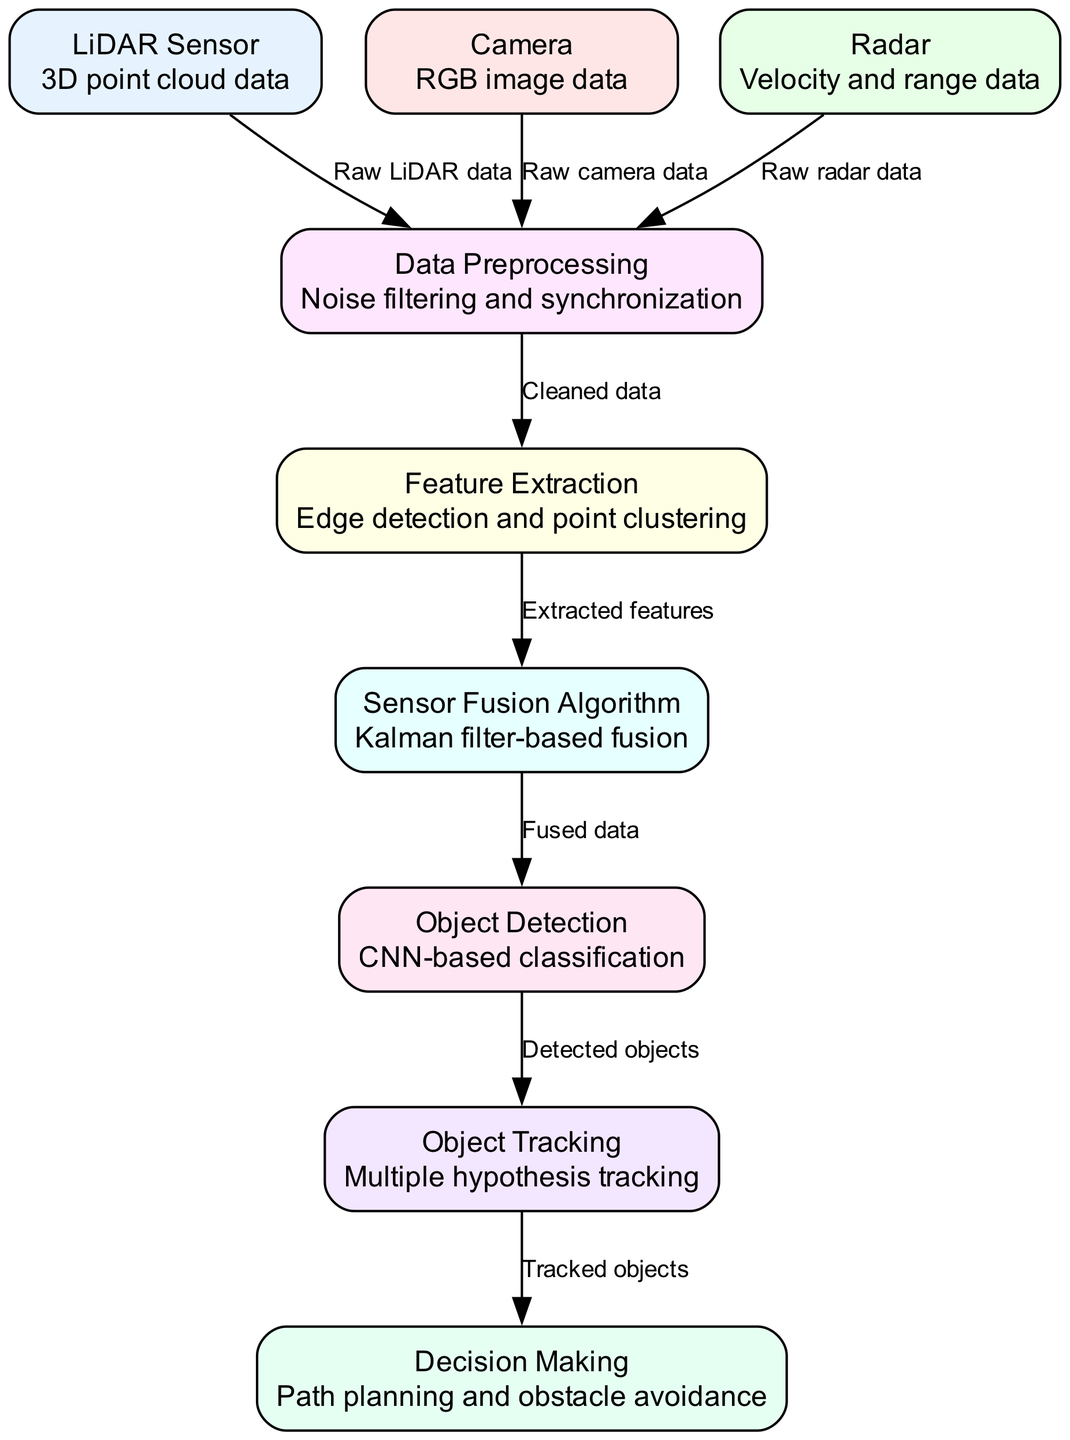What are the three types of sensors used in this diagram? The diagram lists three sensors: LiDAR, Camera, and Radar, which are essential for capturing different types of data.
Answer: LiDAR, Camera, Radar How many nodes are present in the diagram? By counting the nodes listed in the generated diagram data, we find a total of nine distinct nodes representing various components of the system.
Answer: Nine What is the output of the Data Preprocessing node? The output from the Data Preprocessing node is referred to as "Cleaned data," which signifies that the raw data has been modified for further processing.
Answer: Cleaned data What algorithm is used in the Sensor Fusion Algorithm node? The algorithm specified in the Sensor Fusion Algorithm node is based on the Kalman filter, which is a widely used mathematical method for estimating the state of a dynamic system.
Answer: Kalman filter How is object tracking achieved according to the diagram? Object tracking in the diagram is achieved using "Multiple hypothesis tracking," a technique that maintains several possible trajectories for each detected object to determine its accurate path over time.
Answer: Multiple hypothesis tracking What type of data does the Camera provide? The Camera node in the diagram is associated with RGB image data, which provides color visual information for processing and analysis.
Answer: RGB image data Which node represents the final decision-making process in the diagram? The Decision Making node in the diagram signifies the endpoint for processing, where path planning and obstacle avoidance decisions are made based on the processed information from previous nodes.
Answer: Decision Making How does the Object Detection node receive its input? The Object Detection node receives its input from the Sensor Fusion Algorithm, specifically the "Fused data" which combines information from multiple sensors for more accurate object classification.
Answer: Fused data What is the role of Feature Extraction in the diagram? The role of Feature Extraction is to perform edge detection and point clustering, which helps in identifying distinctive patterns or features from the cleaned data before fusion.
Answer: Edge detection and point clustering 